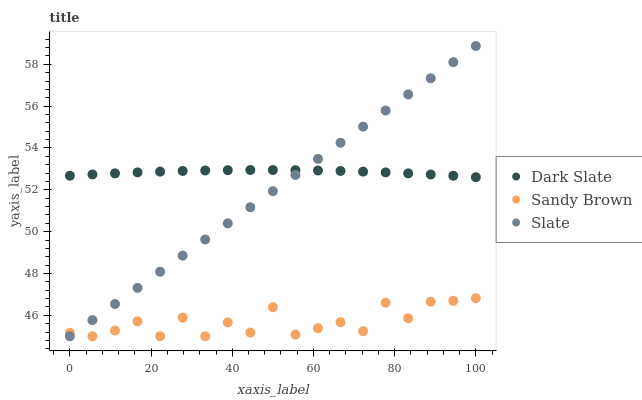Does Sandy Brown have the minimum area under the curve?
Answer yes or no. Yes. Does Dark Slate have the maximum area under the curve?
Answer yes or no. Yes. Does Slate have the minimum area under the curve?
Answer yes or no. No. Does Slate have the maximum area under the curve?
Answer yes or no. No. Is Slate the smoothest?
Answer yes or no. Yes. Is Sandy Brown the roughest?
Answer yes or no. Yes. Is Sandy Brown the smoothest?
Answer yes or no. No. Is Slate the roughest?
Answer yes or no. No. Does Slate have the lowest value?
Answer yes or no. Yes. Does Slate have the highest value?
Answer yes or no. Yes. Does Sandy Brown have the highest value?
Answer yes or no. No. Is Sandy Brown less than Dark Slate?
Answer yes or no. Yes. Is Dark Slate greater than Sandy Brown?
Answer yes or no. Yes. Does Dark Slate intersect Slate?
Answer yes or no. Yes. Is Dark Slate less than Slate?
Answer yes or no. No. Is Dark Slate greater than Slate?
Answer yes or no. No. Does Sandy Brown intersect Dark Slate?
Answer yes or no. No. 